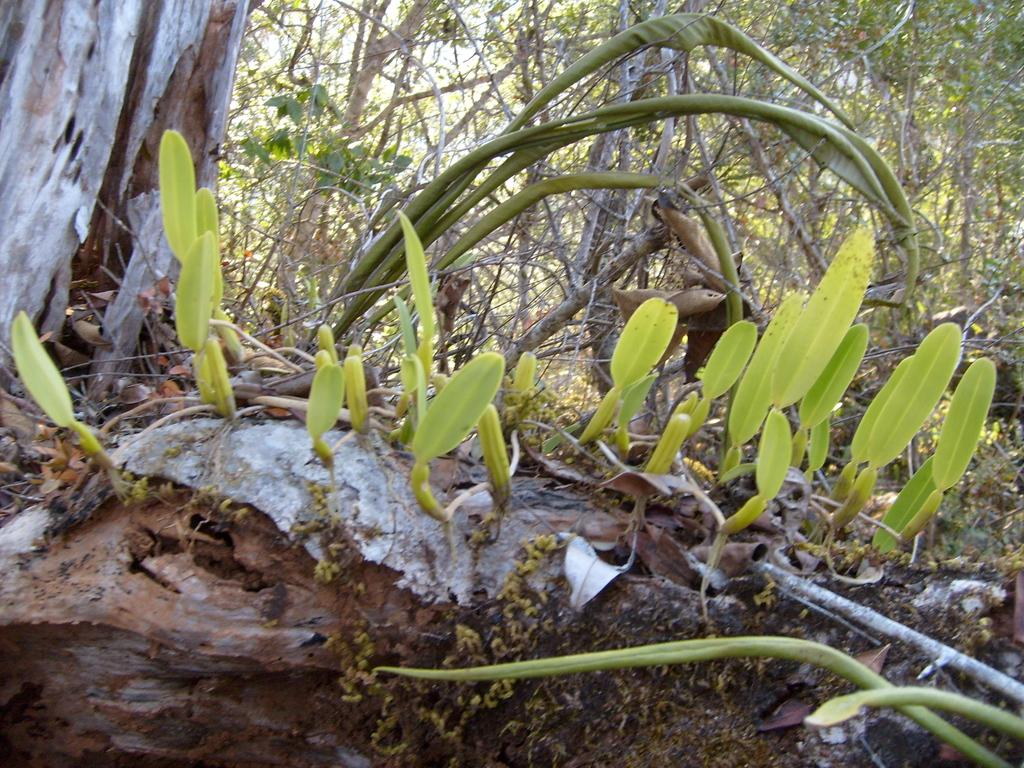What is located in the front of the image? There is a plant in the front of the image. What can be seen in the background of the image? There are trees in the background of the image. What color of paint is used on the robin in the image? There is no robin present in the image, so it is not possible to determine the color of paint used on it. 